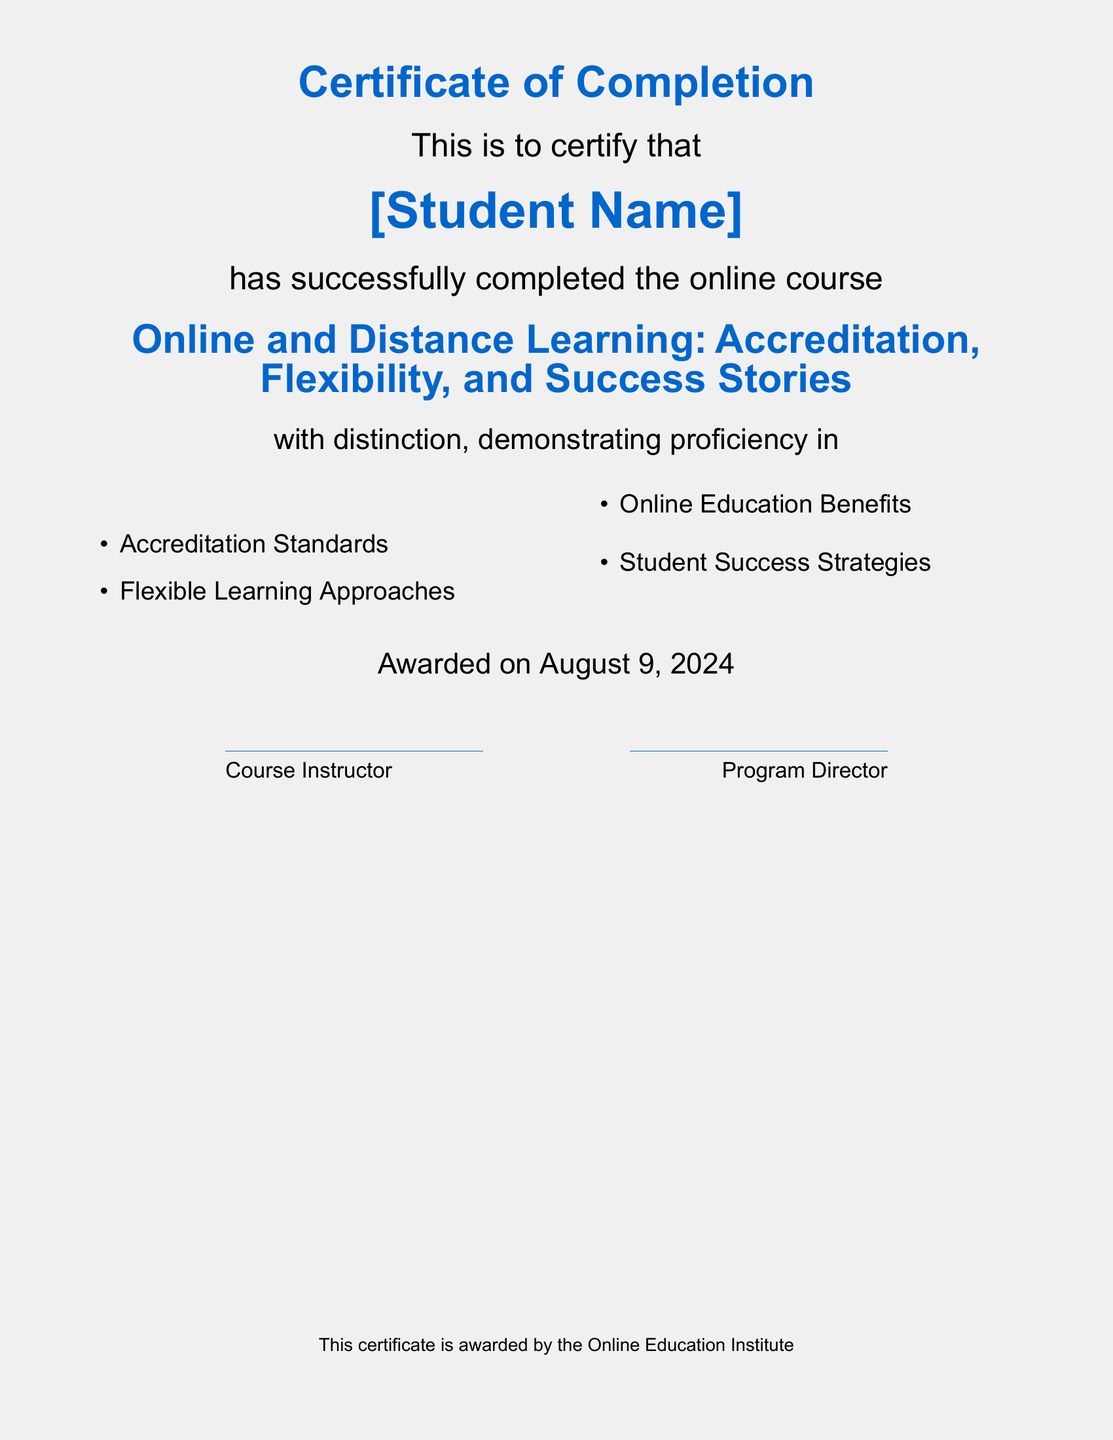What is the title of the course? The title is clearly indicated in the document, forming part of the main header.
Answer: Online and Distance Learning: Accreditation, Flexibility, and Success Stories Who is the issuer of the certificate? The issuer is mentioned at the bottom of the document, indicating the organization that awarded the certificate.
Answer: Online Education Institute What date was the certificate awarded? The awarding date is specified in the document, indicated as “\today.”
Answer: Today's date What are two subjects covered in the course? The subjects are listed in bullet points within the document, and all can be directly taken as answers.
Answer: Accreditation Standards, Flexible Learning Approaches How many items are listed under the proficiency subjects? The number of items is counted based on the list provided in the document.
Answer: Four What does "with distinction" signify in this context? "With distinction" indicates the level of achievement or proficiency demonstrated by the student in the course.
Answer: High achievement What are the names of the people who signed the certificate? The document provides placeholders for those who signed, denoted by their titles.
Answer: Course Instructor, Program Director How many columns are used to display proficiency areas? The proficiency areas are visually separated into different columns in the document.
Answer: Two 